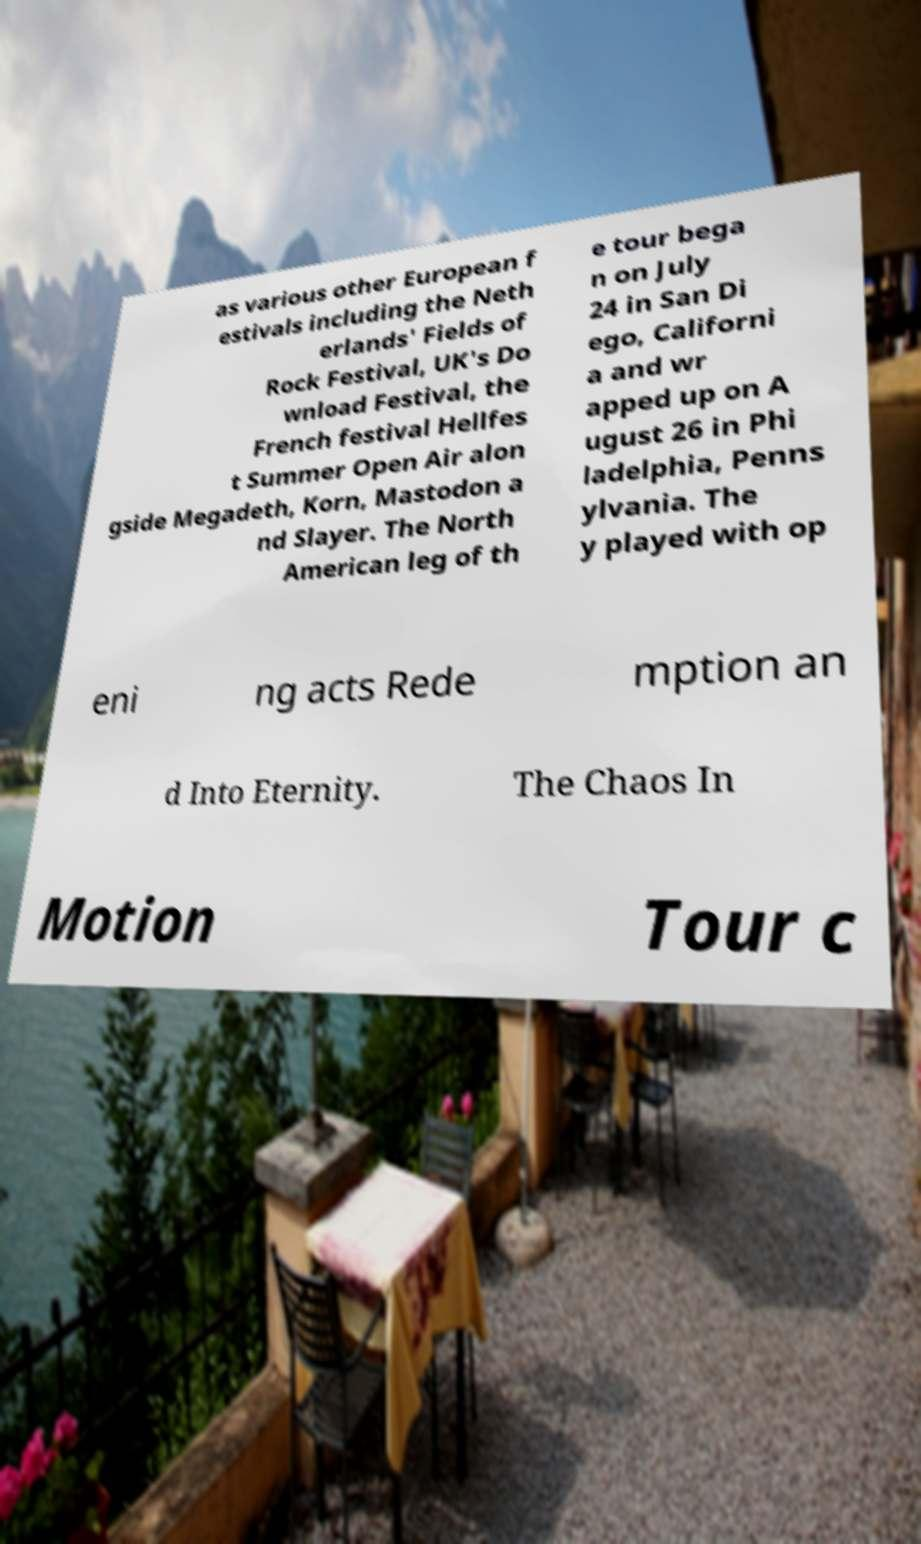Please identify and transcribe the text found in this image. as various other European f estivals including the Neth erlands' Fields of Rock Festival, UK's Do wnload Festival, the French festival Hellfes t Summer Open Air alon gside Megadeth, Korn, Mastodon a nd Slayer. The North American leg of th e tour bega n on July 24 in San Di ego, Californi a and wr apped up on A ugust 26 in Phi ladelphia, Penns ylvania. The y played with op eni ng acts Rede mption an d Into Eternity. The Chaos In Motion Tour c 